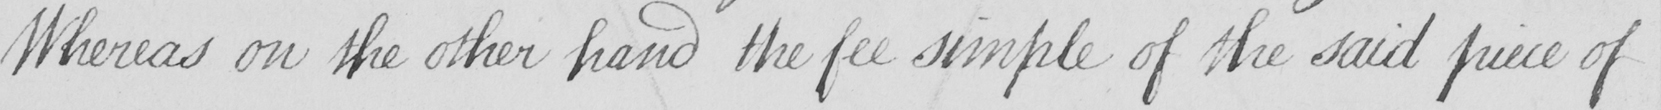Please provide the text content of this handwritten line. Whereas on the other hand the fee simple of the said piece of 